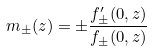Convert formula to latex. <formula><loc_0><loc_0><loc_500><loc_500>m _ { \pm } ( z ) = \pm \frac { f ^ { \prime } _ { \pm } ( 0 , z ) } { f _ { \pm } ( 0 , z ) }</formula> 